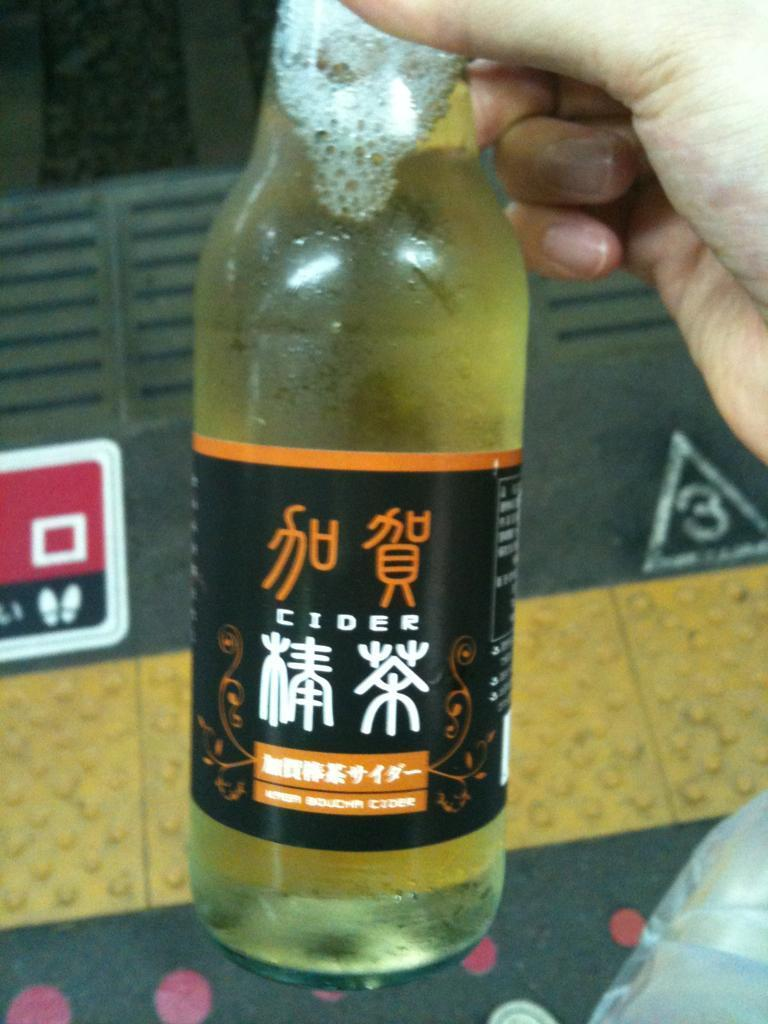What object is being held in the image? There is a bottle in the image. Who is holding the bottle? The bottle is held in a hand. What can be seen at the top of the bottle? The bottle has foam at the neck. What type of beverage is in the bottle? The bottle is labelled as "cider." What color is the background of the label? The background of the label is black. Can you see any giants in the image? No, there are no giants present in the image. What type of vest is being worn by the person holding the bottle? There is no person or vest visible in the image; it only shows a bottle with a label. 